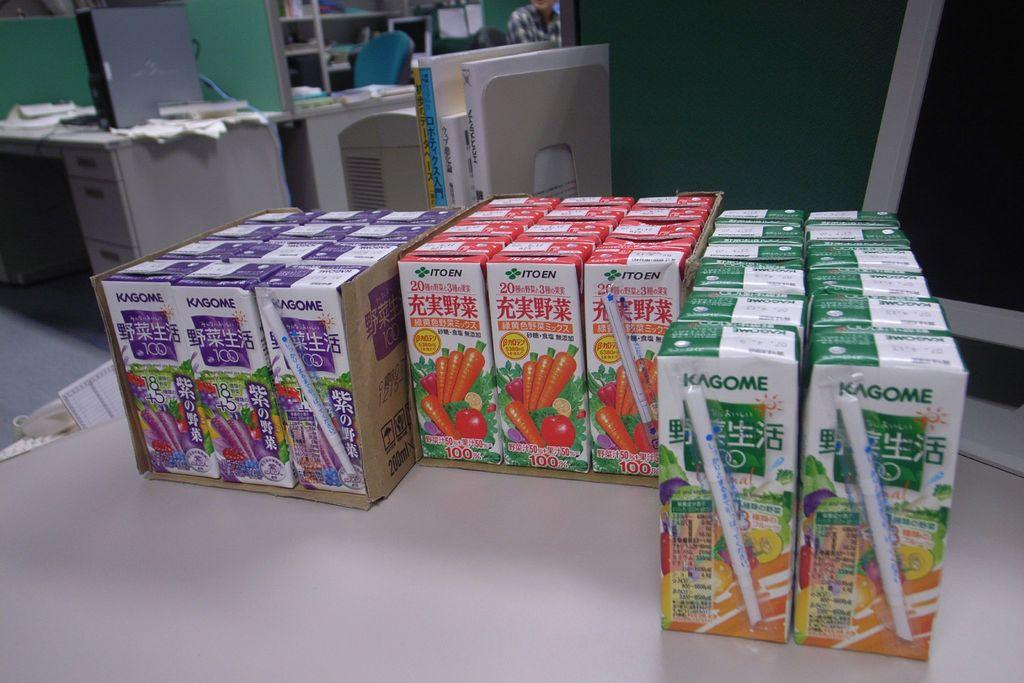<image>
Relay a brief, clear account of the picture shown. Kogome juice boxes come in a variety of different flavors and include an attached straw. 